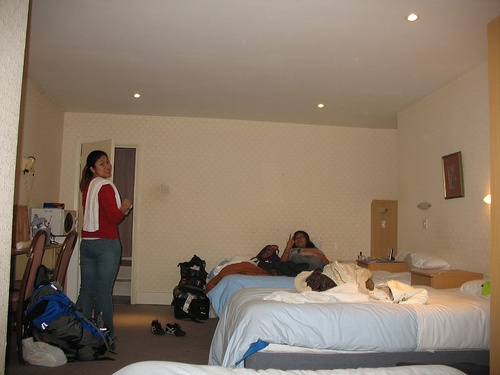Describe the objects in this image and their specific colors. I can see bed in gray, darkgray, and lightgray tones, people in gray, black, maroon, and darkgray tones, backpack in gray, black, navy, and lavender tones, chair in gray, black, and maroon tones, and suitcase in gray and black tones in this image. 